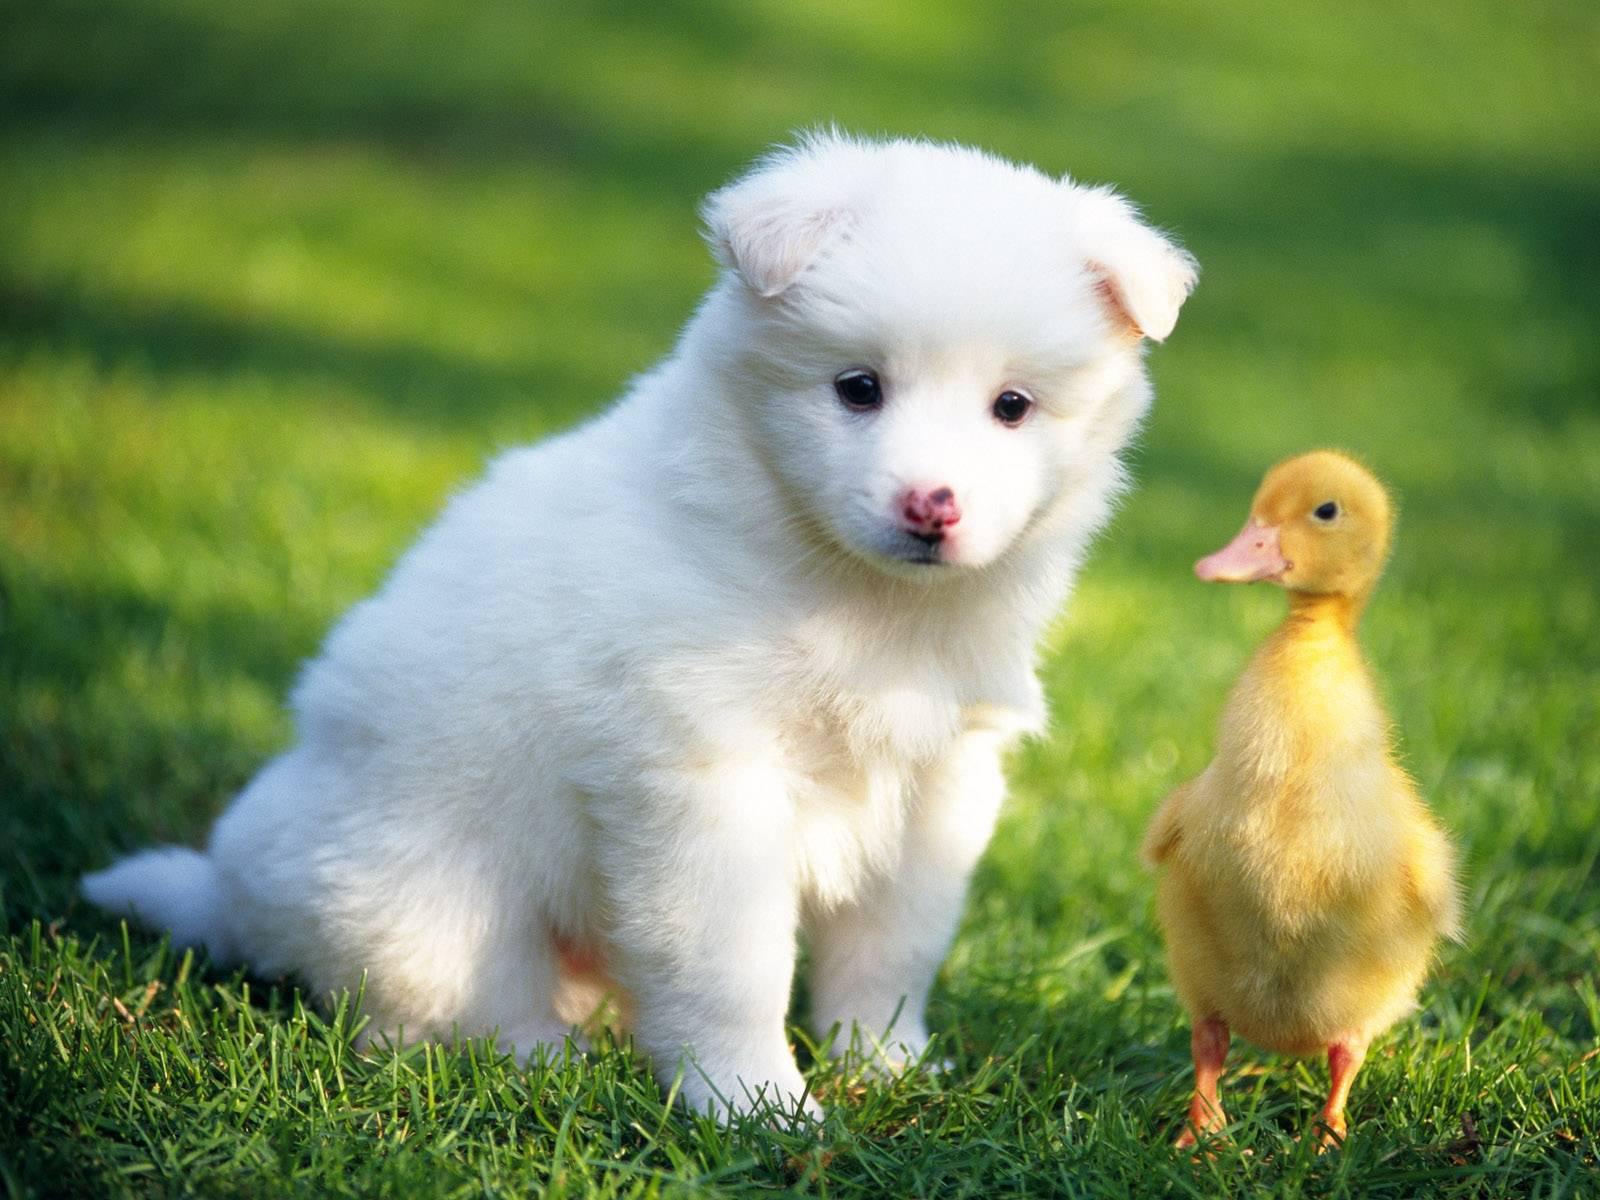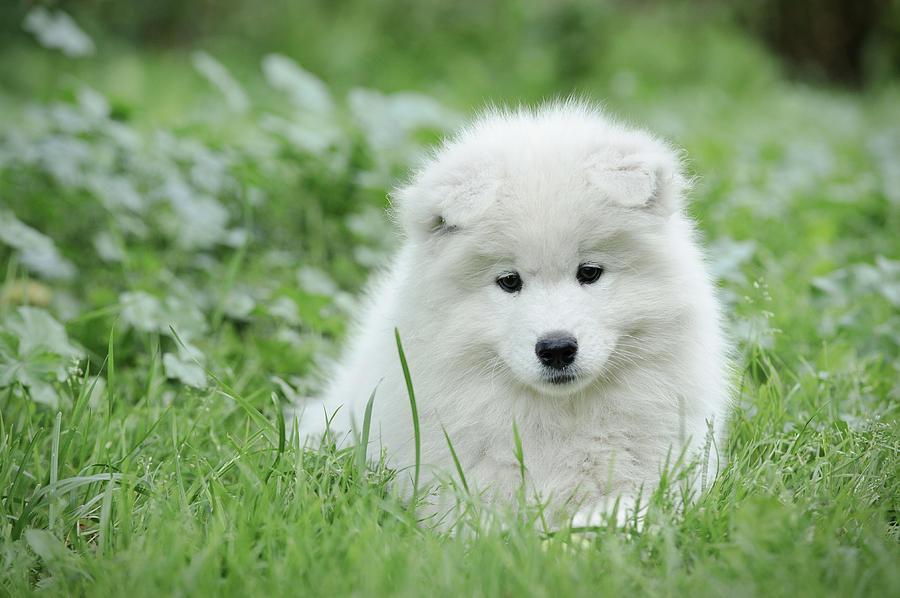The first image is the image on the left, the second image is the image on the right. Examine the images to the left and right. Is the description "The dog on the right has its tongue sticking out." accurate? Answer yes or no. No. 